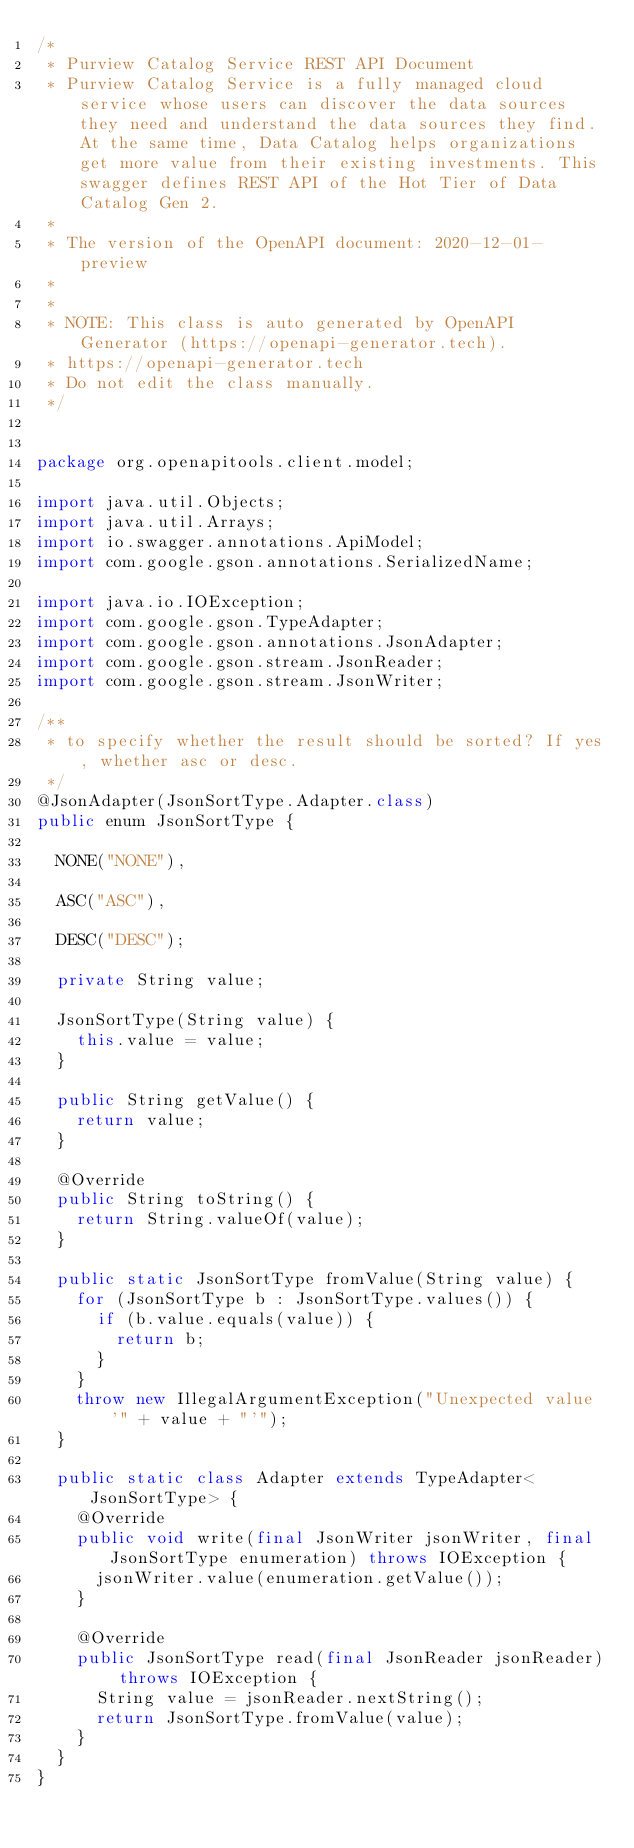Convert code to text. <code><loc_0><loc_0><loc_500><loc_500><_Java_>/*
 * Purview Catalog Service REST API Document
 * Purview Catalog Service is a fully managed cloud service whose users can discover the data sources they need and understand the data sources they find. At the same time, Data Catalog helps organizations get more value from their existing investments. This swagger defines REST API of the Hot Tier of Data Catalog Gen 2.
 *
 * The version of the OpenAPI document: 2020-12-01-preview
 * 
 *
 * NOTE: This class is auto generated by OpenAPI Generator (https://openapi-generator.tech).
 * https://openapi-generator.tech
 * Do not edit the class manually.
 */


package org.openapitools.client.model;

import java.util.Objects;
import java.util.Arrays;
import io.swagger.annotations.ApiModel;
import com.google.gson.annotations.SerializedName;

import java.io.IOException;
import com.google.gson.TypeAdapter;
import com.google.gson.annotations.JsonAdapter;
import com.google.gson.stream.JsonReader;
import com.google.gson.stream.JsonWriter;

/**
 * to specify whether the result should be sorted? If yes, whether asc or desc.
 */
@JsonAdapter(JsonSortType.Adapter.class)
public enum JsonSortType {
  
  NONE("NONE"),
  
  ASC("ASC"),
  
  DESC("DESC");

  private String value;

  JsonSortType(String value) {
    this.value = value;
  }

  public String getValue() {
    return value;
  }

  @Override
  public String toString() {
    return String.valueOf(value);
  }

  public static JsonSortType fromValue(String value) {
    for (JsonSortType b : JsonSortType.values()) {
      if (b.value.equals(value)) {
        return b;
      }
    }
    throw new IllegalArgumentException("Unexpected value '" + value + "'");
  }

  public static class Adapter extends TypeAdapter<JsonSortType> {
    @Override
    public void write(final JsonWriter jsonWriter, final JsonSortType enumeration) throws IOException {
      jsonWriter.value(enumeration.getValue());
    }

    @Override
    public JsonSortType read(final JsonReader jsonReader) throws IOException {
      String value = jsonReader.nextString();
      return JsonSortType.fromValue(value);
    }
  }
}

</code> 